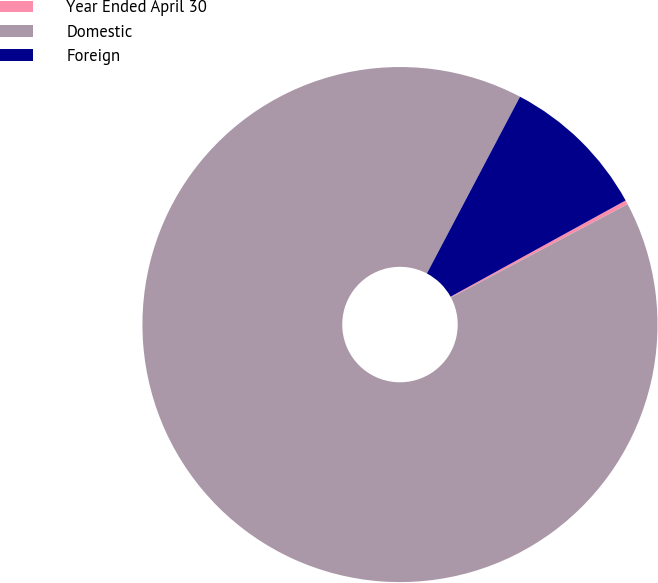Convert chart to OTSL. <chart><loc_0><loc_0><loc_500><loc_500><pie_chart><fcel>Year Ended April 30<fcel>Domestic<fcel>Foreign<nl><fcel>0.26%<fcel>90.46%<fcel>9.28%<nl></chart> 